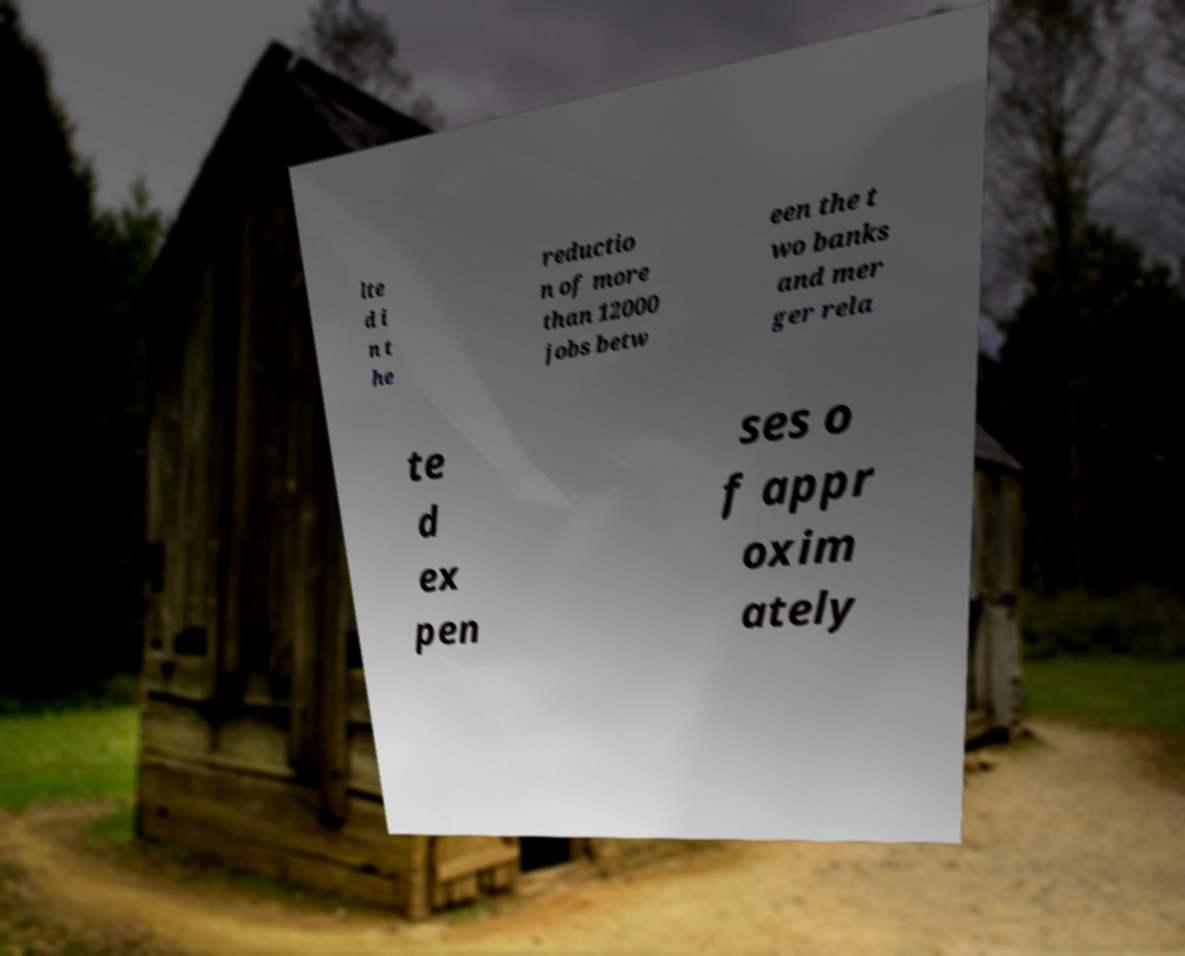Can you accurately transcribe the text from the provided image for me? lte d i n t he reductio n of more than 12000 jobs betw een the t wo banks and mer ger rela te d ex pen ses o f appr oxim ately 